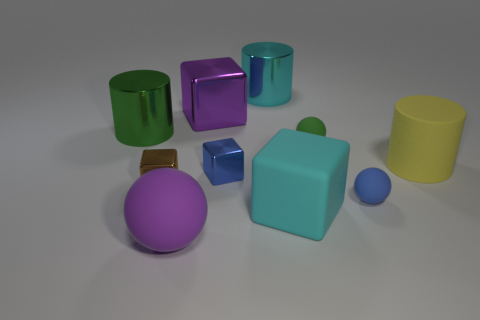Subtract all large purple rubber balls. How many balls are left? 2 Subtract all blue spheres. How many spheres are left? 2 Subtract all blocks. How many objects are left? 6 Subtract all gray cylinders. How many cyan blocks are left? 1 Subtract all large metallic things. Subtract all metallic cubes. How many objects are left? 4 Add 2 big purple metallic objects. How many big purple metallic objects are left? 3 Add 3 large metal cubes. How many large metal cubes exist? 4 Subtract 0 red blocks. How many objects are left? 10 Subtract 1 cubes. How many cubes are left? 3 Subtract all cyan blocks. Subtract all yellow cylinders. How many blocks are left? 3 